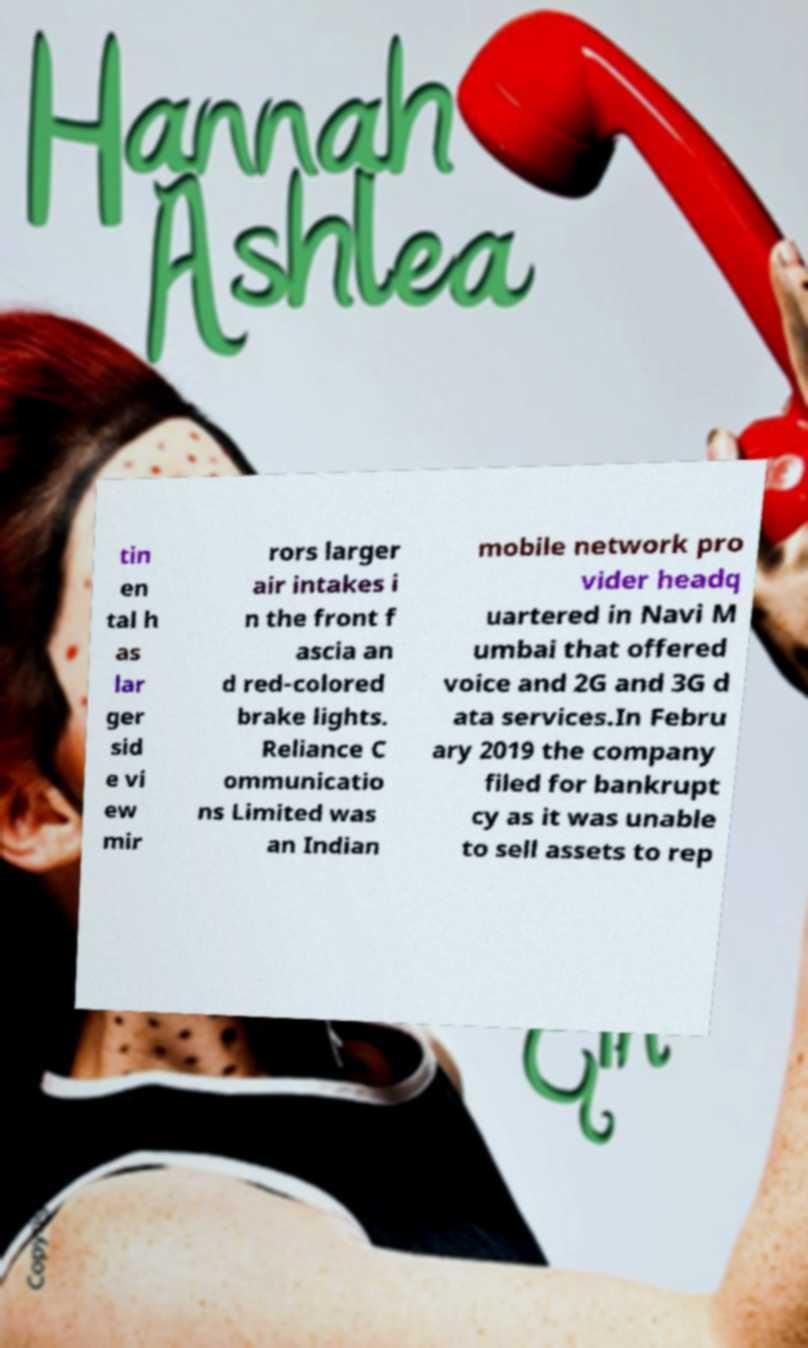There's text embedded in this image that I need extracted. Can you transcribe it verbatim? tin en tal h as lar ger sid e vi ew mir rors larger air intakes i n the front f ascia an d red-colored brake lights. Reliance C ommunicatio ns Limited was an Indian mobile network pro vider headq uartered in Navi M umbai that offered voice and 2G and 3G d ata services.In Febru ary 2019 the company filed for bankrupt cy as it was unable to sell assets to rep 